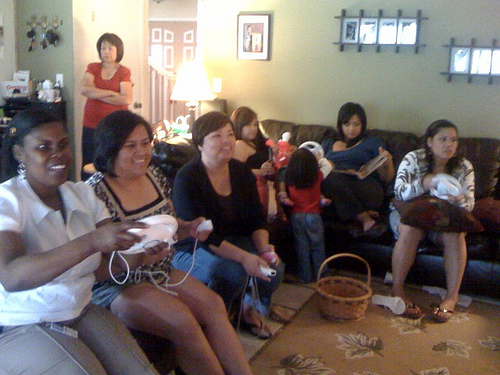<image>What is the team name? It is ambiguous which team name is referred to. It could be 'cougars', 'team', or 'family'. What is the team name? I am not sure what the team name is. It can be 'none', 'don't know', 'unknown', 'no team', or 'team'. 